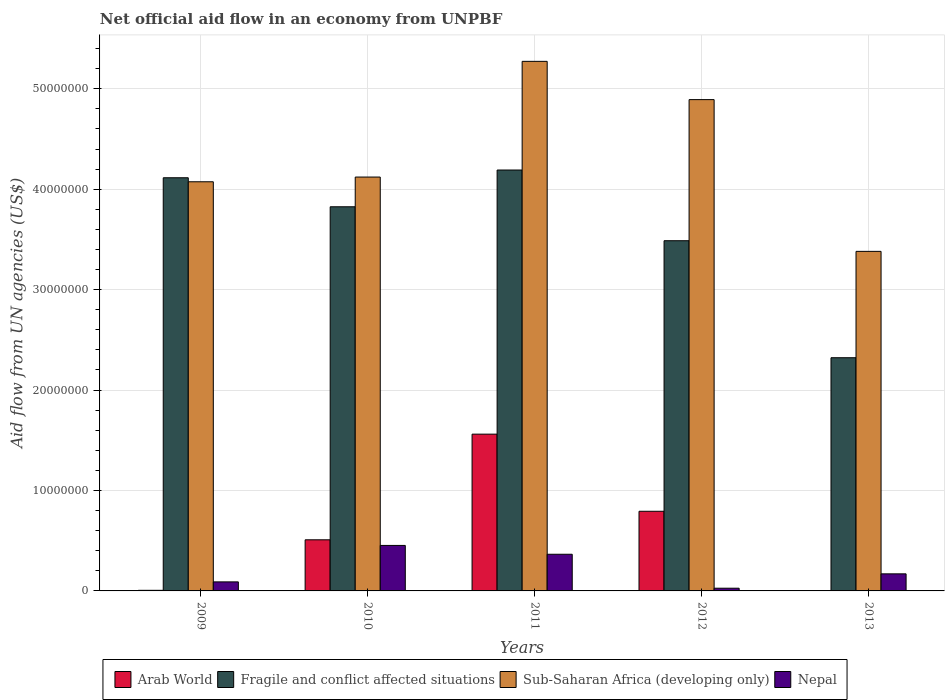How many different coloured bars are there?
Give a very brief answer. 4. How many groups of bars are there?
Offer a very short reply. 5. In how many cases, is the number of bars for a given year not equal to the number of legend labels?
Provide a succinct answer. 1. What is the net official aid flow in Sub-Saharan Africa (developing only) in 2010?
Your answer should be very brief. 4.12e+07. Across all years, what is the maximum net official aid flow in Sub-Saharan Africa (developing only)?
Provide a succinct answer. 5.27e+07. Across all years, what is the minimum net official aid flow in Fragile and conflict affected situations?
Your answer should be very brief. 2.32e+07. In which year was the net official aid flow in Arab World maximum?
Offer a very short reply. 2011. What is the total net official aid flow in Arab World in the graph?
Your answer should be compact. 2.87e+07. What is the difference between the net official aid flow in Nepal in 2009 and that in 2013?
Provide a succinct answer. -8.00e+05. What is the difference between the net official aid flow in Fragile and conflict affected situations in 2011 and the net official aid flow in Sub-Saharan Africa (developing only) in 2009?
Make the answer very short. 1.17e+06. What is the average net official aid flow in Arab World per year?
Offer a very short reply. 5.74e+06. In the year 2011, what is the difference between the net official aid flow in Fragile and conflict affected situations and net official aid flow in Nepal?
Make the answer very short. 3.83e+07. What is the ratio of the net official aid flow in Sub-Saharan Africa (developing only) in 2011 to that in 2013?
Provide a short and direct response. 1.56. Is the difference between the net official aid flow in Fragile and conflict affected situations in 2010 and 2011 greater than the difference between the net official aid flow in Nepal in 2010 and 2011?
Your response must be concise. No. What is the difference between the highest and the second highest net official aid flow in Arab World?
Provide a succinct answer. 7.68e+06. What is the difference between the highest and the lowest net official aid flow in Fragile and conflict affected situations?
Provide a succinct answer. 1.87e+07. Is the sum of the net official aid flow in Fragile and conflict affected situations in 2010 and 2011 greater than the maximum net official aid flow in Nepal across all years?
Offer a very short reply. Yes. Is it the case that in every year, the sum of the net official aid flow in Arab World and net official aid flow in Fragile and conflict affected situations is greater than the sum of net official aid flow in Sub-Saharan Africa (developing only) and net official aid flow in Nepal?
Provide a short and direct response. Yes. Is it the case that in every year, the sum of the net official aid flow in Arab World and net official aid flow in Fragile and conflict affected situations is greater than the net official aid flow in Nepal?
Your answer should be compact. Yes. How many bars are there?
Your answer should be compact. 19. How many years are there in the graph?
Your answer should be compact. 5. What is the difference between two consecutive major ticks on the Y-axis?
Offer a terse response. 1.00e+07. Does the graph contain any zero values?
Ensure brevity in your answer.  Yes. Does the graph contain grids?
Your response must be concise. Yes. Where does the legend appear in the graph?
Make the answer very short. Bottom center. How many legend labels are there?
Ensure brevity in your answer.  4. What is the title of the graph?
Offer a very short reply. Net official aid flow in an economy from UNPBF. Does "Afghanistan" appear as one of the legend labels in the graph?
Your answer should be compact. No. What is the label or title of the X-axis?
Provide a succinct answer. Years. What is the label or title of the Y-axis?
Ensure brevity in your answer.  Aid flow from UN agencies (US$). What is the Aid flow from UN agencies (US$) in Arab World in 2009?
Provide a succinct answer. 6.00e+04. What is the Aid flow from UN agencies (US$) in Fragile and conflict affected situations in 2009?
Ensure brevity in your answer.  4.11e+07. What is the Aid flow from UN agencies (US$) in Sub-Saharan Africa (developing only) in 2009?
Provide a short and direct response. 4.07e+07. What is the Aid flow from UN agencies (US$) in Nepal in 2009?
Your answer should be compact. 9.00e+05. What is the Aid flow from UN agencies (US$) of Arab World in 2010?
Your response must be concise. 5.09e+06. What is the Aid flow from UN agencies (US$) of Fragile and conflict affected situations in 2010?
Offer a very short reply. 3.82e+07. What is the Aid flow from UN agencies (US$) of Sub-Saharan Africa (developing only) in 2010?
Give a very brief answer. 4.12e+07. What is the Aid flow from UN agencies (US$) in Nepal in 2010?
Your answer should be compact. 4.53e+06. What is the Aid flow from UN agencies (US$) of Arab World in 2011?
Keep it short and to the point. 1.56e+07. What is the Aid flow from UN agencies (US$) in Fragile and conflict affected situations in 2011?
Offer a very short reply. 4.19e+07. What is the Aid flow from UN agencies (US$) in Sub-Saharan Africa (developing only) in 2011?
Provide a succinct answer. 5.27e+07. What is the Aid flow from UN agencies (US$) of Nepal in 2011?
Your answer should be compact. 3.65e+06. What is the Aid flow from UN agencies (US$) in Arab World in 2012?
Your answer should be compact. 7.93e+06. What is the Aid flow from UN agencies (US$) in Fragile and conflict affected situations in 2012?
Your answer should be compact. 3.49e+07. What is the Aid flow from UN agencies (US$) in Sub-Saharan Africa (developing only) in 2012?
Ensure brevity in your answer.  4.89e+07. What is the Aid flow from UN agencies (US$) of Arab World in 2013?
Offer a terse response. 0. What is the Aid flow from UN agencies (US$) of Fragile and conflict affected situations in 2013?
Offer a terse response. 2.32e+07. What is the Aid flow from UN agencies (US$) of Sub-Saharan Africa (developing only) in 2013?
Offer a terse response. 3.38e+07. What is the Aid flow from UN agencies (US$) in Nepal in 2013?
Offer a terse response. 1.70e+06. Across all years, what is the maximum Aid flow from UN agencies (US$) in Arab World?
Make the answer very short. 1.56e+07. Across all years, what is the maximum Aid flow from UN agencies (US$) in Fragile and conflict affected situations?
Provide a short and direct response. 4.19e+07. Across all years, what is the maximum Aid flow from UN agencies (US$) of Sub-Saharan Africa (developing only)?
Your answer should be compact. 5.27e+07. Across all years, what is the maximum Aid flow from UN agencies (US$) in Nepal?
Your answer should be compact. 4.53e+06. Across all years, what is the minimum Aid flow from UN agencies (US$) of Arab World?
Your answer should be very brief. 0. Across all years, what is the minimum Aid flow from UN agencies (US$) of Fragile and conflict affected situations?
Offer a very short reply. 2.32e+07. Across all years, what is the minimum Aid flow from UN agencies (US$) of Sub-Saharan Africa (developing only)?
Your response must be concise. 3.38e+07. What is the total Aid flow from UN agencies (US$) of Arab World in the graph?
Your answer should be compact. 2.87e+07. What is the total Aid flow from UN agencies (US$) of Fragile and conflict affected situations in the graph?
Ensure brevity in your answer.  1.79e+08. What is the total Aid flow from UN agencies (US$) in Sub-Saharan Africa (developing only) in the graph?
Make the answer very short. 2.17e+08. What is the total Aid flow from UN agencies (US$) of Nepal in the graph?
Offer a very short reply. 1.10e+07. What is the difference between the Aid flow from UN agencies (US$) of Arab World in 2009 and that in 2010?
Keep it short and to the point. -5.03e+06. What is the difference between the Aid flow from UN agencies (US$) in Fragile and conflict affected situations in 2009 and that in 2010?
Make the answer very short. 2.89e+06. What is the difference between the Aid flow from UN agencies (US$) of Sub-Saharan Africa (developing only) in 2009 and that in 2010?
Offer a terse response. -4.70e+05. What is the difference between the Aid flow from UN agencies (US$) of Nepal in 2009 and that in 2010?
Offer a terse response. -3.63e+06. What is the difference between the Aid flow from UN agencies (US$) in Arab World in 2009 and that in 2011?
Your answer should be compact. -1.56e+07. What is the difference between the Aid flow from UN agencies (US$) in Fragile and conflict affected situations in 2009 and that in 2011?
Offer a very short reply. -7.70e+05. What is the difference between the Aid flow from UN agencies (US$) in Sub-Saharan Africa (developing only) in 2009 and that in 2011?
Provide a succinct answer. -1.20e+07. What is the difference between the Aid flow from UN agencies (US$) of Nepal in 2009 and that in 2011?
Offer a terse response. -2.75e+06. What is the difference between the Aid flow from UN agencies (US$) of Arab World in 2009 and that in 2012?
Offer a very short reply. -7.87e+06. What is the difference between the Aid flow from UN agencies (US$) of Fragile and conflict affected situations in 2009 and that in 2012?
Your answer should be compact. 6.27e+06. What is the difference between the Aid flow from UN agencies (US$) in Sub-Saharan Africa (developing only) in 2009 and that in 2012?
Offer a very short reply. -8.18e+06. What is the difference between the Aid flow from UN agencies (US$) in Nepal in 2009 and that in 2012?
Ensure brevity in your answer.  6.30e+05. What is the difference between the Aid flow from UN agencies (US$) in Fragile and conflict affected situations in 2009 and that in 2013?
Provide a short and direct response. 1.79e+07. What is the difference between the Aid flow from UN agencies (US$) of Sub-Saharan Africa (developing only) in 2009 and that in 2013?
Offer a very short reply. 6.93e+06. What is the difference between the Aid flow from UN agencies (US$) of Nepal in 2009 and that in 2013?
Ensure brevity in your answer.  -8.00e+05. What is the difference between the Aid flow from UN agencies (US$) in Arab World in 2010 and that in 2011?
Ensure brevity in your answer.  -1.05e+07. What is the difference between the Aid flow from UN agencies (US$) of Fragile and conflict affected situations in 2010 and that in 2011?
Your answer should be compact. -3.66e+06. What is the difference between the Aid flow from UN agencies (US$) in Sub-Saharan Africa (developing only) in 2010 and that in 2011?
Your answer should be compact. -1.15e+07. What is the difference between the Aid flow from UN agencies (US$) of Nepal in 2010 and that in 2011?
Offer a terse response. 8.80e+05. What is the difference between the Aid flow from UN agencies (US$) in Arab World in 2010 and that in 2012?
Offer a very short reply. -2.84e+06. What is the difference between the Aid flow from UN agencies (US$) in Fragile and conflict affected situations in 2010 and that in 2012?
Give a very brief answer. 3.38e+06. What is the difference between the Aid flow from UN agencies (US$) in Sub-Saharan Africa (developing only) in 2010 and that in 2012?
Offer a terse response. -7.71e+06. What is the difference between the Aid flow from UN agencies (US$) in Nepal in 2010 and that in 2012?
Provide a succinct answer. 4.26e+06. What is the difference between the Aid flow from UN agencies (US$) of Fragile and conflict affected situations in 2010 and that in 2013?
Provide a short and direct response. 1.50e+07. What is the difference between the Aid flow from UN agencies (US$) in Sub-Saharan Africa (developing only) in 2010 and that in 2013?
Offer a very short reply. 7.40e+06. What is the difference between the Aid flow from UN agencies (US$) of Nepal in 2010 and that in 2013?
Your answer should be compact. 2.83e+06. What is the difference between the Aid flow from UN agencies (US$) of Arab World in 2011 and that in 2012?
Provide a short and direct response. 7.68e+06. What is the difference between the Aid flow from UN agencies (US$) in Fragile and conflict affected situations in 2011 and that in 2012?
Ensure brevity in your answer.  7.04e+06. What is the difference between the Aid flow from UN agencies (US$) in Sub-Saharan Africa (developing only) in 2011 and that in 2012?
Make the answer very short. 3.81e+06. What is the difference between the Aid flow from UN agencies (US$) of Nepal in 2011 and that in 2012?
Your response must be concise. 3.38e+06. What is the difference between the Aid flow from UN agencies (US$) of Fragile and conflict affected situations in 2011 and that in 2013?
Provide a short and direct response. 1.87e+07. What is the difference between the Aid flow from UN agencies (US$) in Sub-Saharan Africa (developing only) in 2011 and that in 2013?
Offer a very short reply. 1.89e+07. What is the difference between the Aid flow from UN agencies (US$) of Nepal in 2011 and that in 2013?
Offer a very short reply. 1.95e+06. What is the difference between the Aid flow from UN agencies (US$) in Fragile and conflict affected situations in 2012 and that in 2013?
Keep it short and to the point. 1.16e+07. What is the difference between the Aid flow from UN agencies (US$) of Sub-Saharan Africa (developing only) in 2012 and that in 2013?
Offer a very short reply. 1.51e+07. What is the difference between the Aid flow from UN agencies (US$) in Nepal in 2012 and that in 2013?
Provide a succinct answer. -1.43e+06. What is the difference between the Aid flow from UN agencies (US$) of Arab World in 2009 and the Aid flow from UN agencies (US$) of Fragile and conflict affected situations in 2010?
Offer a terse response. -3.82e+07. What is the difference between the Aid flow from UN agencies (US$) of Arab World in 2009 and the Aid flow from UN agencies (US$) of Sub-Saharan Africa (developing only) in 2010?
Give a very brief answer. -4.12e+07. What is the difference between the Aid flow from UN agencies (US$) in Arab World in 2009 and the Aid flow from UN agencies (US$) in Nepal in 2010?
Provide a succinct answer. -4.47e+06. What is the difference between the Aid flow from UN agencies (US$) of Fragile and conflict affected situations in 2009 and the Aid flow from UN agencies (US$) of Sub-Saharan Africa (developing only) in 2010?
Your answer should be very brief. -7.00e+04. What is the difference between the Aid flow from UN agencies (US$) in Fragile and conflict affected situations in 2009 and the Aid flow from UN agencies (US$) in Nepal in 2010?
Make the answer very short. 3.66e+07. What is the difference between the Aid flow from UN agencies (US$) in Sub-Saharan Africa (developing only) in 2009 and the Aid flow from UN agencies (US$) in Nepal in 2010?
Make the answer very short. 3.62e+07. What is the difference between the Aid flow from UN agencies (US$) of Arab World in 2009 and the Aid flow from UN agencies (US$) of Fragile and conflict affected situations in 2011?
Provide a short and direct response. -4.18e+07. What is the difference between the Aid flow from UN agencies (US$) in Arab World in 2009 and the Aid flow from UN agencies (US$) in Sub-Saharan Africa (developing only) in 2011?
Your response must be concise. -5.27e+07. What is the difference between the Aid flow from UN agencies (US$) in Arab World in 2009 and the Aid flow from UN agencies (US$) in Nepal in 2011?
Make the answer very short. -3.59e+06. What is the difference between the Aid flow from UN agencies (US$) in Fragile and conflict affected situations in 2009 and the Aid flow from UN agencies (US$) in Sub-Saharan Africa (developing only) in 2011?
Provide a succinct answer. -1.16e+07. What is the difference between the Aid flow from UN agencies (US$) of Fragile and conflict affected situations in 2009 and the Aid flow from UN agencies (US$) of Nepal in 2011?
Your response must be concise. 3.75e+07. What is the difference between the Aid flow from UN agencies (US$) of Sub-Saharan Africa (developing only) in 2009 and the Aid flow from UN agencies (US$) of Nepal in 2011?
Provide a short and direct response. 3.71e+07. What is the difference between the Aid flow from UN agencies (US$) in Arab World in 2009 and the Aid flow from UN agencies (US$) in Fragile and conflict affected situations in 2012?
Offer a terse response. -3.48e+07. What is the difference between the Aid flow from UN agencies (US$) in Arab World in 2009 and the Aid flow from UN agencies (US$) in Sub-Saharan Africa (developing only) in 2012?
Your answer should be very brief. -4.89e+07. What is the difference between the Aid flow from UN agencies (US$) in Fragile and conflict affected situations in 2009 and the Aid flow from UN agencies (US$) in Sub-Saharan Africa (developing only) in 2012?
Make the answer very short. -7.78e+06. What is the difference between the Aid flow from UN agencies (US$) in Fragile and conflict affected situations in 2009 and the Aid flow from UN agencies (US$) in Nepal in 2012?
Your response must be concise. 4.09e+07. What is the difference between the Aid flow from UN agencies (US$) of Sub-Saharan Africa (developing only) in 2009 and the Aid flow from UN agencies (US$) of Nepal in 2012?
Provide a short and direct response. 4.05e+07. What is the difference between the Aid flow from UN agencies (US$) of Arab World in 2009 and the Aid flow from UN agencies (US$) of Fragile and conflict affected situations in 2013?
Your response must be concise. -2.32e+07. What is the difference between the Aid flow from UN agencies (US$) of Arab World in 2009 and the Aid flow from UN agencies (US$) of Sub-Saharan Africa (developing only) in 2013?
Offer a terse response. -3.38e+07. What is the difference between the Aid flow from UN agencies (US$) of Arab World in 2009 and the Aid flow from UN agencies (US$) of Nepal in 2013?
Give a very brief answer. -1.64e+06. What is the difference between the Aid flow from UN agencies (US$) in Fragile and conflict affected situations in 2009 and the Aid flow from UN agencies (US$) in Sub-Saharan Africa (developing only) in 2013?
Give a very brief answer. 7.33e+06. What is the difference between the Aid flow from UN agencies (US$) in Fragile and conflict affected situations in 2009 and the Aid flow from UN agencies (US$) in Nepal in 2013?
Make the answer very short. 3.94e+07. What is the difference between the Aid flow from UN agencies (US$) of Sub-Saharan Africa (developing only) in 2009 and the Aid flow from UN agencies (US$) of Nepal in 2013?
Keep it short and to the point. 3.90e+07. What is the difference between the Aid flow from UN agencies (US$) of Arab World in 2010 and the Aid flow from UN agencies (US$) of Fragile and conflict affected situations in 2011?
Keep it short and to the point. -3.68e+07. What is the difference between the Aid flow from UN agencies (US$) of Arab World in 2010 and the Aid flow from UN agencies (US$) of Sub-Saharan Africa (developing only) in 2011?
Keep it short and to the point. -4.76e+07. What is the difference between the Aid flow from UN agencies (US$) in Arab World in 2010 and the Aid flow from UN agencies (US$) in Nepal in 2011?
Offer a terse response. 1.44e+06. What is the difference between the Aid flow from UN agencies (US$) in Fragile and conflict affected situations in 2010 and the Aid flow from UN agencies (US$) in Sub-Saharan Africa (developing only) in 2011?
Give a very brief answer. -1.45e+07. What is the difference between the Aid flow from UN agencies (US$) in Fragile and conflict affected situations in 2010 and the Aid flow from UN agencies (US$) in Nepal in 2011?
Your answer should be very brief. 3.46e+07. What is the difference between the Aid flow from UN agencies (US$) in Sub-Saharan Africa (developing only) in 2010 and the Aid flow from UN agencies (US$) in Nepal in 2011?
Your answer should be compact. 3.76e+07. What is the difference between the Aid flow from UN agencies (US$) of Arab World in 2010 and the Aid flow from UN agencies (US$) of Fragile and conflict affected situations in 2012?
Make the answer very short. -2.98e+07. What is the difference between the Aid flow from UN agencies (US$) of Arab World in 2010 and the Aid flow from UN agencies (US$) of Sub-Saharan Africa (developing only) in 2012?
Offer a terse response. -4.38e+07. What is the difference between the Aid flow from UN agencies (US$) in Arab World in 2010 and the Aid flow from UN agencies (US$) in Nepal in 2012?
Keep it short and to the point. 4.82e+06. What is the difference between the Aid flow from UN agencies (US$) in Fragile and conflict affected situations in 2010 and the Aid flow from UN agencies (US$) in Sub-Saharan Africa (developing only) in 2012?
Make the answer very short. -1.07e+07. What is the difference between the Aid flow from UN agencies (US$) in Fragile and conflict affected situations in 2010 and the Aid flow from UN agencies (US$) in Nepal in 2012?
Your answer should be compact. 3.80e+07. What is the difference between the Aid flow from UN agencies (US$) in Sub-Saharan Africa (developing only) in 2010 and the Aid flow from UN agencies (US$) in Nepal in 2012?
Your response must be concise. 4.09e+07. What is the difference between the Aid flow from UN agencies (US$) of Arab World in 2010 and the Aid flow from UN agencies (US$) of Fragile and conflict affected situations in 2013?
Keep it short and to the point. -1.81e+07. What is the difference between the Aid flow from UN agencies (US$) in Arab World in 2010 and the Aid flow from UN agencies (US$) in Sub-Saharan Africa (developing only) in 2013?
Your answer should be very brief. -2.87e+07. What is the difference between the Aid flow from UN agencies (US$) in Arab World in 2010 and the Aid flow from UN agencies (US$) in Nepal in 2013?
Keep it short and to the point. 3.39e+06. What is the difference between the Aid flow from UN agencies (US$) in Fragile and conflict affected situations in 2010 and the Aid flow from UN agencies (US$) in Sub-Saharan Africa (developing only) in 2013?
Ensure brevity in your answer.  4.44e+06. What is the difference between the Aid flow from UN agencies (US$) of Fragile and conflict affected situations in 2010 and the Aid flow from UN agencies (US$) of Nepal in 2013?
Your response must be concise. 3.66e+07. What is the difference between the Aid flow from UN agencies (US$) in Sub-Saharan Africa (developing only) in 2010 and the Aid flow from UN agencies (US$) in Nepal in 2013?
Provide a succinct answer. 3.95e+07. What is the difference between the Aid flow from UN agencies (US$) of Arab World in 2011 and the Aid flow from UN agencies (US$) of Fragile and conflict affected situations in 2012?
Offer a very short reply. -1.93e+07. What is the difference between the Aid flow from UN agencies (US$) of Arab World in 2011 and the Aid flow from UN agencies (US$) of Sub-Saharan Africa (developing only) in 2012?
Keep it short and to the point. -3.33e+07. What is the difference between the Aid flow from UN agencies (US$) in Arab World in 2011 and the Aid flow from UN agencies (US$) in Nepal in 2012?
Your answer should be compact. 1.53e+07. What is the difference between the Aid flow from UN agencies (US$) in Fragile and conflict affected situations in 2011 and the Aid flow from UN agencies (US$) in Sub-Saharan Africa (developing only) in 2012?
Your answer should be very brief. -7.01e+06. What is the difference between the Aid flow from UN agencies (US$) in Fragile and conflict affected situations in 2011 and the Aid flow from UN agencies (US$) in Nepal in 2012?
Give a very brief answer. 4.16e+07. What is the difference between the Aid flow from UN agencies (US$) of Sub-Saharan Africa (developing only) in 2011 and the Aid flow from UN agencies (US$) of Nepal in 2012?
Provide a succinct answer. 5.25e+07. What is the difference between the Aid flow from UN agencies (US$) in Arab World in 2011 and the Aid flow from UN agencies (US$) in Fragile and conflict affected situations in 2013?
Give a very brief answer. -7.61e+06. What is the difference between the Aid flow from UN agencies (US$) in Arab World in 2011 and the Aid flow from UN agencies (US$) in Sub-Saharan Africa (developing only) in 2013?
Ensure brevity in your answer.  -1.82e+07. What is the difference between the Aid flow from UN agencies (US$) of Arab World in 2011 and the Aid flow from UN agencies (US$) of Nepal in 2013?
Make the answer very short. 1.39e+07. What is the difference between the Aid flow from UN agencies (US$) of Fragile and conflict affected situations in 2011 and the Aid flow from UN agencies (US$) of Sub-Saharan Africa (developing only) in 2013?
Keep it short and to the point. 8.10e+06. What is the difference between the Aid flow from UN agencies (US$) in Fragile and conflict affected situations in 2011 and the Aid flow from UN agencies (US$) in Nepal in 2013?
Offer a very short reply. 4.02e+07. What is the difference between the Aid flow from UN agencies (US$) in Sub-Saharan Africa (developing only) in 2011 and the Aid flow from UN agencies (US$) in Nepal in 2013?
Offer a very short reply. 5.10e+07. What is the difference between the Aid flow from UN agencies (US$) of Arab World in 2012 and the Aid flow from UN agencies (US$) of Fragile and conflict affected situations in 2013?
Offer a terse response. -1.53e+07. What is the difference between the Aid flow from UN agencies (US$) of Arab World in 2012 and the Aid flow from UN agencies (US$) of Sub-Saharan Africa (developing only) in 2013?
Ensure brevity in your answer.  -2.59e+07. What is the difference between the Aid flow from UN agencies (US$) of Arab World in 2012 and the Aid flow from UN agencies (US$) of Nepal in 2013?
Your answer should be very brief. 6.23e+06. What is the difference between the Aid flow from UN agencies (US$) in Fragile and conflict affected situations in 2012 and the Aid flow from UN agencies (US$) in Sub-Saharan Africa (developing only) in 2013?
Ensure brevity in your answer.  1.06e+06. What is the difference between the Aid flow from UN agencies (US$) of Fragile and conflict affected situations in 2012 and the Aid flow from UN agencies (US$) of Nepal in 2013?
Offer a terse response. 3.32e+07. What is the difference between the Aid flow from UN agencies (US$) in Sub-Saharan Africa (developing only) in 2012 and the Aid flow from UN agencies (US$) in Nepal in 2013?
Give a very brief answer. 4.72e+07. What is the average Aid flow from UN agencies (US$) in Arab World per year?
Your response must be concise. 5.74e+06. What is the average Aid flow from UN agencies (US$) of Fragile and conflict affected situations per year?
Keep it short and to the point. 3.59e+07. What is the average Aid flow from UN agencies (US$) in Sub-Saharan Africa (developing only) per year?
Your answer should be compact. 4.35e+07. What is the average Aid flow from UN agencies (US$) of Nepal per year?
Your answer should be compact. 2.21e+06. In the year 2009, what is the difference between the Aid flow from UN agencies (US$) in Arab World and Aid flow from UN agencies (US$) in Fragile and conflict affected situations?
Provide a succinct answer. -4.11e+07. In the year 2009, what is the difference between the Aid flow from UN agencies (US$) of Arab World and Aid flow from UN agencies (US$) of Sub-Saharan Africa (developing only)?
Make the answer very short. -4.07e+07. In the year 2009, what is the difference between the Aid flow from UN agencies (US$) of Arab World and Aid flow from UN agencies (US$) of Nepal?
Your response must be concise. -8.40e+05. In the year 2009, what is the difference between the Aid flow from UN agencies (US$) of Fragile and conflict affected situations and Aid flow from UN agencies (US$) of Nepal?
Offer a terse response. 4.02e+07. In the year 2009, what is the difference between the Aid flow from UN agencies (US$) of Sub-Saharan Africa (developing only) and Aid flow from UN agencies (US$) of Nepal?
Your answer should be compact. 3.98e+07. In the year 2010, what is the difference between the Aid flow from UN agencies (US$) in Arab World and Aid flow from UN agencies (US$) in Fragile and conflict affected situations?
Provide a succinct answer. -3.32e+07. In the year 2010, what is the difference between the Aid flow from UN agencies (US$) in Arab World and Aid flow from UN agencies (US$) in Sub-Saharan Africa (developing only)?
Your answer should be compact. -3.61e+07. In the year 2010, what is the difference between the Aid flow from UN agencies (US$) of Arab World and Aid flow from UN agencies (US$) of Nepal?
Your response must be concise. 5.60e+05. In the year 2010, what is the difference between the Aid flow from UN agencies (US$) of Fragile and conflict affected situations and Aid flow from UN agencies (US$) of Sub-Saharan Africa (developing only)?
Your answer should be very brief. -2.96e+06. In the year 2010, what is the difference between the Aid flow from UN agencies (US$) of Fragile and conflict affected situations and Aid flow from UN agencies (US$) of Nepal?
Provide a short and direct response. 3.37e+07. In the year 2010, what is the difference between the Aid flow from UN agencies (US$) in Sub-Saharan Africa (developing only) and Aid flow from UN agencies (US$) in Nepal?
Offer a terse response. 3.67e+07. In the year 2011, what is the difference between the Aid flow from UN agencies (US$) in Arab World and Aid flow from UN agencies (US$) in Fragile and conflict affected situations?
Offer a terse response. -2.63e+07. In the year 2011, what is the difference between the Aid flow from UN agencies (US$) in Arab World and Aid flow from UN agencies (US$) in Sub-Saharan Africa (developing only)?
Your answer should be very brief. -3.71e+07. In the year 2011, what is the difference between the Aid flow from UN agencies (US$) in Arab World and Aid flow from UN agencies (US$) in Nepal?
Your answer should be very brief. 1.20e+07. In the year 2011, what is the difference between the Aid flow from UN agencies (US$) in Fragile and conflict affected situations and Aid flow from UN agencies (US$) in Sub-Saharan Africa (developing only)?
Your response must be concise. -1.08e+07. In the year 2011, what is the difference between the Aid flow from UN agencies (US$) in Fragile and conflict affected situations and Aid flow from UN agencies (US$) in Nepal?
Provide a short and direct response. 3.83e+07. In the year 2011, what is the difference between the Aid flow from UN agencies (US$) in Sub-Saharan Africa (developing only) and Aid flow from UN agencies (US$) in Nepal?
Give a very brief answer. 4.91e+07. In the year 2012, what is the difference between the Aid flow from UN agencies (US$) in Arab World and Aid flow from UN agencies (US$) in Fragile and conflict affected situations?
Provide a short and direct response. -2.69e+07. In the year 2012, what is the difference between the Aid flow from UN agencies (US$) in Arab World and Aid flow from UN agencies (US$) in Sub-Saharan Africa (developing only)?
Provide a succinct answer. -4.10e+07. In the year 2012, what is the difference between the Aid flow from UN agencies (US$) of Arab World and Aid flow from UN agencies (US$) of Nepal?
Ensure brevity in your answer.  7.66e+06. In the year 2012, what is the difference between the Aid flow from UN agencies (US$) of Fragile and conflict affected situations and Aid flow from UN agencies (US$) of Sub-Saharan Africa (developing only)?
Your answer should be compact. -1.40e+07. In the year 2012, what is the difference between the Aid flow from UN agencies (US$) of Fragile and conflict affected situations and Aid flow from UN agencies (US$) of Nepal?
Make the answer very short. 3.46e+07. In the year 2012, what is the difference between the Aid flow from UN agencies (US$) in Sub-Saharan Africa (developing only) and Aid flow from UN agencies (US$) in Nepal?
Provide a short and direct response. 4.86e+07. In the year 2013, what is the difference between the Aid flow from UN agencies (US$) in Fragile and conflict affected situations and Aid flow from UN agencies (US$) in Sub-Saharan Africa (developing only)?
Offer a very short reply. -1.06e+07. In the year 2013, what is the difference between the Aid flow from UN agencies (US$) in Fragile and conflict affected situations and Aid flow from UN agencies (US$) in Nepal?
Your answer should be compact. 2.15e+07. In the year 2013, what is the difference between the Aid flow from UN agencies (US$) of Sub-Saharan Africa (developing only) and Aid flow from UN agencies (US$) of Nepal?
Keep it short and to the point. 3.21e+07. What is the ratio of the Aid flow from UN agencies (US$) in Arab World in 2009 to that in 2010?
Provide a succinct answer. 0.01. What is the ratio of the Aid flow from UN agencies (US$) in Fragile and conflict affected situations in 2009 to that in 2010?
Offer a very short reply. 1.08. What is the ratio of the Aid flow from UN agencies (US$) in Nepal in 2009 to that in 2010?
Ensure brevity in your answer.  0.2. What is the ratio of the Aid flow from UN agencies (US$) in Arab World in 2009 to that in 2011?
Your answer should be compact. 0. What is the ratio of the Aid flow from UN agencies (US$) in Fragile and conflict affected situations in 2009 to that in 2011?
Your response must be concise. 0.98. What is the ratio of the Aid flow from UN agencies (US$) in Sub-Saharan Africa (developing only) in 2009 to that in 2011?
Ensure brevity in your answer.  0.77. What is the ratio of the Aid flow from UN agencies (US$) of Nepal in 2009 to that in 2011?
Provide a short and direct response. 0.25. What is the ratio of the Aid flow from UN agencies (US$) of Arab World in 2009 to that in 2012?
Offer a very short reply. 0.01. What is the ratio of the Aid flow from UN agencies (US$) in Fragile and conflict affected situations in 2009 to that in 2012?
Offer a terse response. 1.18. What is the ratio of the Aid flow from UN agencies (US$) in Sub-Saharan Africa (developing only) in 2009 to that in 2012?
Keep it short and to the point. 0.83. What is the ratio of the Aid flow from UN agencies (US$) in Nepal in 2009 to that in 2012?
Ensure brevity in your answer.  3.33. What is the ratio of the Aid flow from UN agencies (US$) of Fragile and conflict affected situations in 2009 to that in 2013?
Provide a succinct answer. 1.77. What is the ratio of the Aid flow from UN agencies (US$) of Sub-Saharan Africa (developing only) in 2009 to that in 2013?
Give a very brief answer. 1.21. What is the ratio of the Aid flow from UN agencies (US$) of Nepal in 2009 to that in 2013?
Give a very brief answer. 0.53. What is the ratio of the Aid flow from UN agencies (US$) of Arab World in 2010 to that in 2011?
Your response must be concise. 0.33. What is the ratio of the Aid flow from UN agencies (US$) in Fragile and conflict affected situations in 2010 to that in 2011?
Your answer should be very brief. 0.91. What is the ratio of the Aid flow from UN agencies (US$) in Sub-Saharan Africa (developing only) in 2010 to that in 2011?
Offer a terse response. 0.78. What is the ratio of the Aid flow from UN agencies (US$) in Nepal in 2010 to that in 2011?
Keep it short and to the point. 1.24. What is the ratio of the Aid flow from UN agencies (US$) of Arab World in 2010 to that in 2012?
Offer a very short reply. 0.64. What is the ratio of the Aid flow from UN agencies (US$) of Fragile and conflict affected situations in 2010 to that in 2012?
Your answer should be very brief. 1.1. What is the ratio of the Aid flow from UN agencies (US$) of Sub-Saharan Africa (developing only) in 2010 to that in 2012?
Your answer should be very brief. 0.84. What is the ratio of the Aid flow from UN agencies (US$) of Nepal in 2010 to that in 2012?
Ensure brevity in your answer.  16.78. What is the ratio of the Aid flow from UN agencies (US$) of Fragile and conflict affected situations in 2010 to that in 2013?
Offer a terse response. 1.65. What is the ratio of the Aid flow from UN agencies (US$) of Sub-Saharan Africa (developing only) in 2010 to that in 2013?
Provide a succinct answer. 1.22. What is the ratio of the Aid flow from UN agencies (US$) in Nepal in 2010 to that in 2013?
Your answer should be very brief. 2.66. What is the ratio of the Aid flow from UN agencies (US$) in Arab World in 2011 to that in 2012?
Your answer should be very brief. 1.97. What is the ratio of the Aid flow from UN agencies (US$) in Fragile and conflict affected situations in 2011 to that in 2012?
Your answer should be very brief. 1.2. What is the ratio of the Aid flow from UN agencies (US$) in Sub-Saharan Africa (developing only) in 2011 to that in 2012?
Provide a short and direct response. 1.08. What is the ratio of the Aid flow from UN agencies (US$) in Nepal in 2011 to that in 2012?
Keep it short and to the point. 13.52. What is the ratio of the Aid flow from UN agencies (US$) of Fragile and conflict affected situations in 2011 to that in 2013?
Your response must be concise. 1.8. What is the ratio of the Aid flow from UN agencies (US$) in Sub-Saharan Africa (developing only) in 2011 to that in 2013?
Make the answer very short. 1.56. What is the ratio of the Aid flow from UN agencies (US$) of Nepal in 2011 to that in 2013?
Offer a very short reply. 2.15. What is the ratio of the Aid flow from UN agencies (US$) in Fragile and conflict affected situations in 2012 to that in 2013?
Provide a short and direct response. 1.5. What is the ratio of the Aid flow from UN agencies (US$) in Sub-Saharan Africa (developing only) in 2012 to that in 2013?
Provide a short and direct response. 1.45. What is the ratio of the Aid flow from UN agencies (US$) of Nepal in 2012 to that in 2013?
Make the answer very short. 0.16. What is the difference between the highest and the second highest Aid flow from UN agencies (US$) in Arab World?
Your response must be concise. 7.68e+06. What is the difference between the highest and the second highest Aid flow from UN agencies (US$) of Fragile and conflict affected situations?
Provide a succinct answer. 7.70e+05. What is the difference between the highest and the second highest Aid flow from UN agencies (US$) of Sub-Saharan Africa (developing only)?
Offer a very short reply. 3.81e+06. What is the difference between the highest and the second highest Aid flow from UN agencies (US$) of Nepal?
Provide a short and direct response. 8.80e+05. What is the difference between the highest and the lowest Aid flow from UN agencies (US$) of Arab World?
Your answer should be compact. 1.56e+07. What is the difference between the highest and the lowest Aid flow from UN agencies (US$) of Fragile and conflict affected situations?
Ensure brevity in your answer.  1.87e+07. What is the difference between the highest and the lowest Aid flow from UN agencies (US$) in Sub-Saharan Africa (developing only)?
Provide a succinct answer. 1.89e+07. What is the difference between the highest and the lowest Aid flow from UN agencies (US$) in Nepal?
Your answer should be very brief. 4.26e+06. 